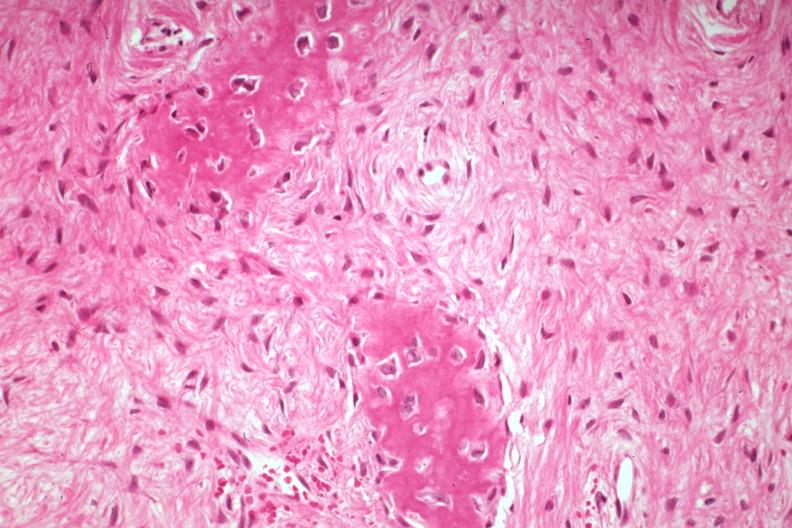s joints present?
Answer the question using a single word or phrase. Yes 